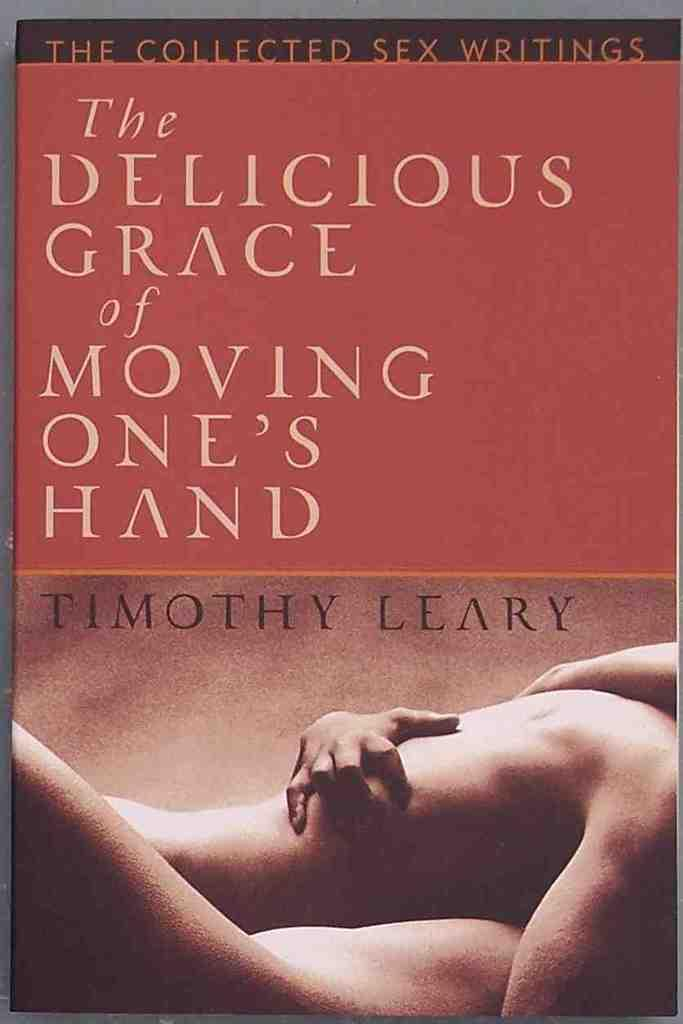Provide a one-sentence caption for the provided image. A book about sex lays on a surface. 